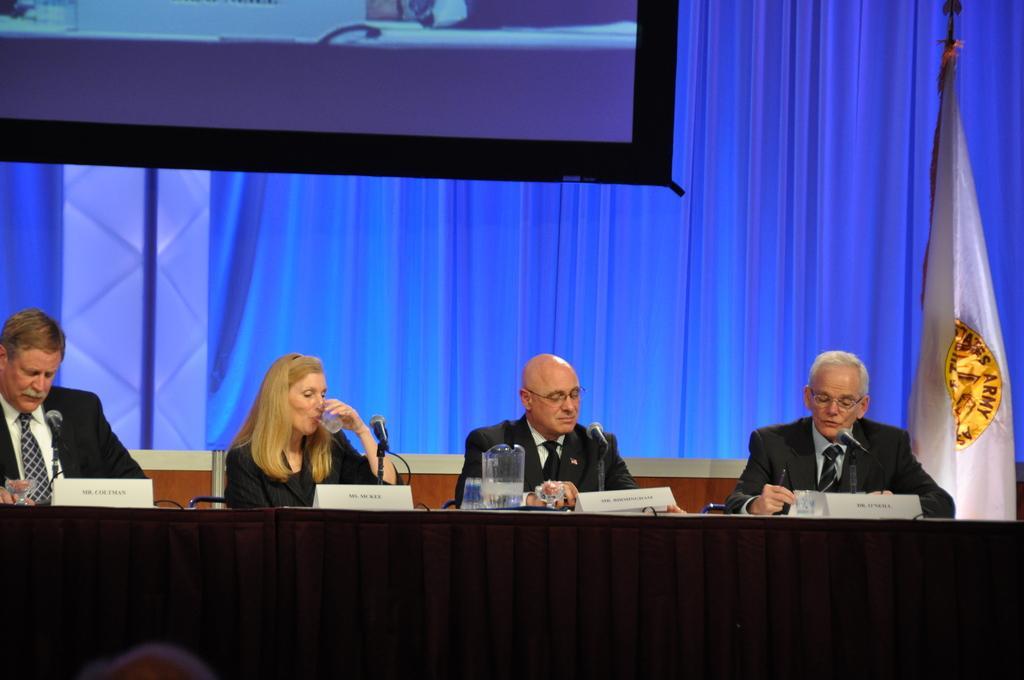Please provide a concise description of this image. In front of the image we can see the head of a person. There are people sitting on the chairs. In front of them there is a table. On top of it there are name boards, mike's, glasses and a jar. On the right side of the image there is a flag. In the background of the image there is a screen and there are curtains. 